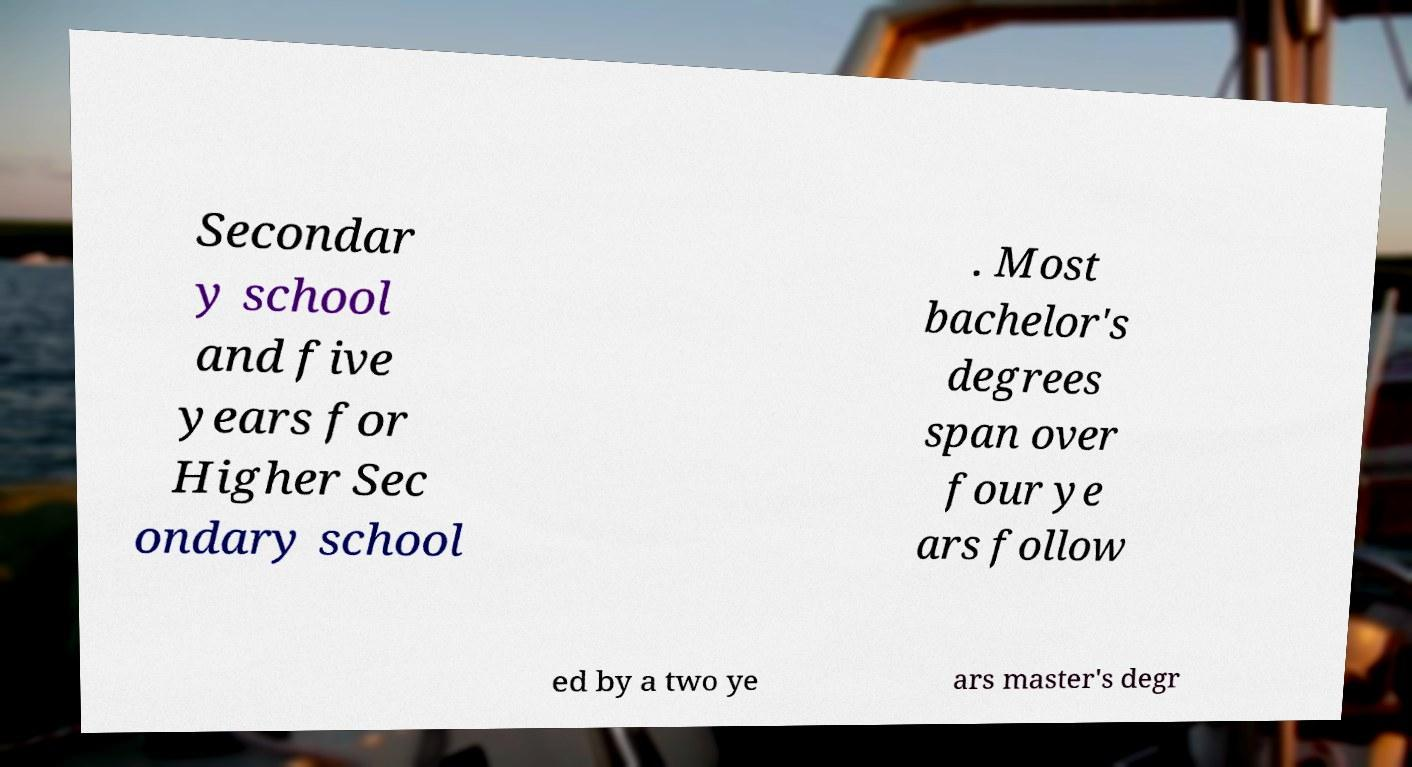Please read and relay the text visible in this image. What does it say? Secondar y school and five years for Higher Sec ondary school . Most bachelor's degrees span over four ye ars follow ed by a two ye ars master's degr 